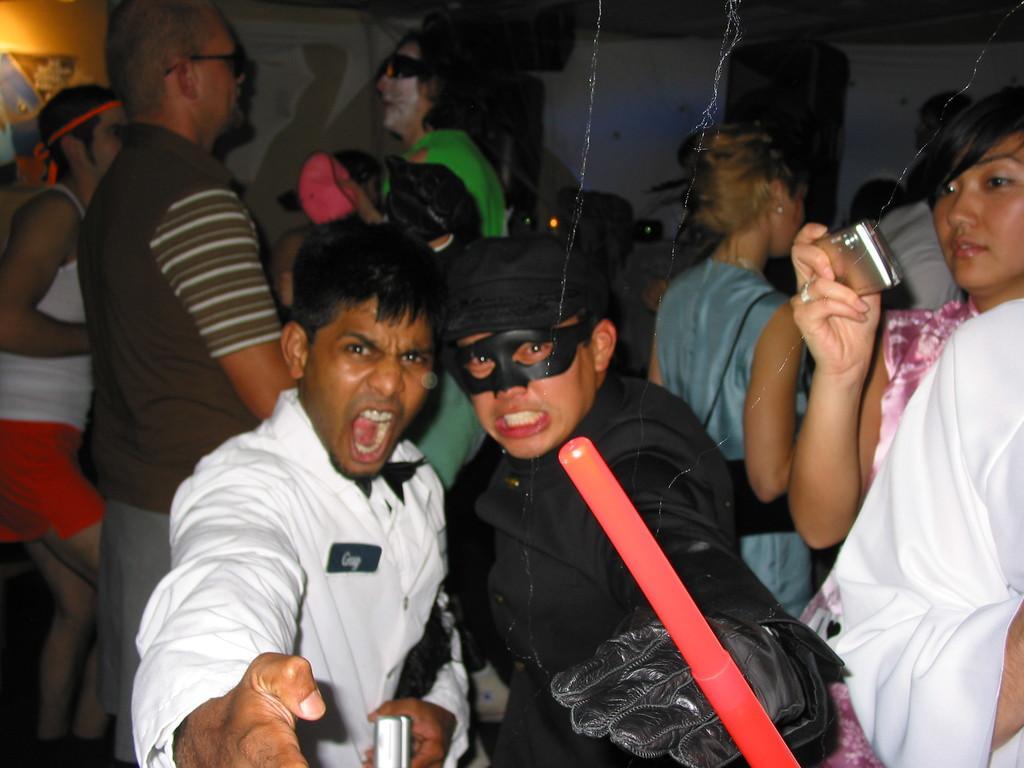How would you summarize this image in a sentence or two? In this picture I can see number of people in which few of them are wearing costumes and the woman on the right is holding an electronic device. On the top left corner of this picture I can see the light. 